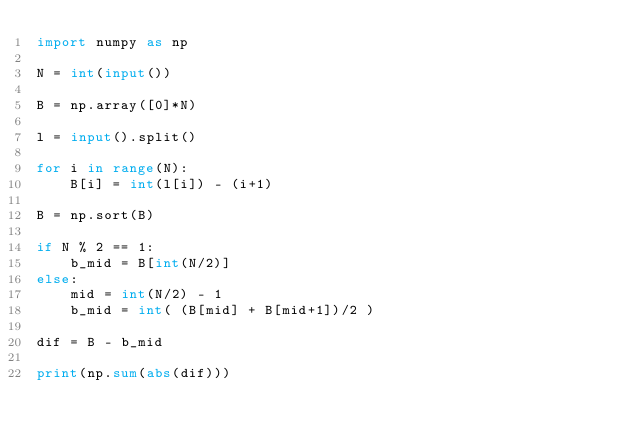<code> <loc_0><loc_0><loc_500><loc_500><_Python_>import numpy as np

N = int(input())

B = np.array([0]*N)

l = input().split()

for i in range(N):
    B[i] = int(l[i]) - (i+1)
    
B = np.sort(B)

if N % 2 == 1:
    b_mid = B[int(N/2)]
else:
    mid = int(N/2) - 1
    b_mid = int( (B[mid] + B[mid+1])/2 )

dif = B - b_mid

print(np.sum(abs(dif)))</code> 